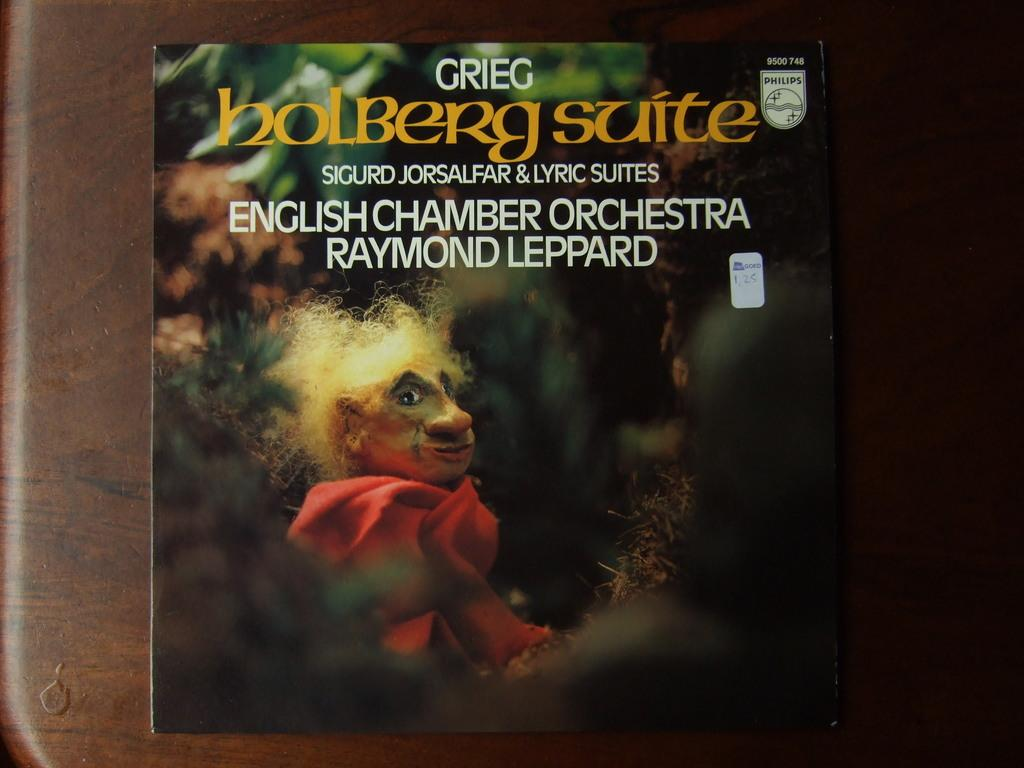What is featured on the poster in the image? The poster contains text and an image. What type of surface is the poster attached to? The poster is on a wooden wall. What flavor of ice cream is depicted in the poster's image? There is no ice cream depicted in the poster's image; it contains a different subject. What type of bird is shown perched on the poster? There is no bird, specifically a wren, present in the image. 